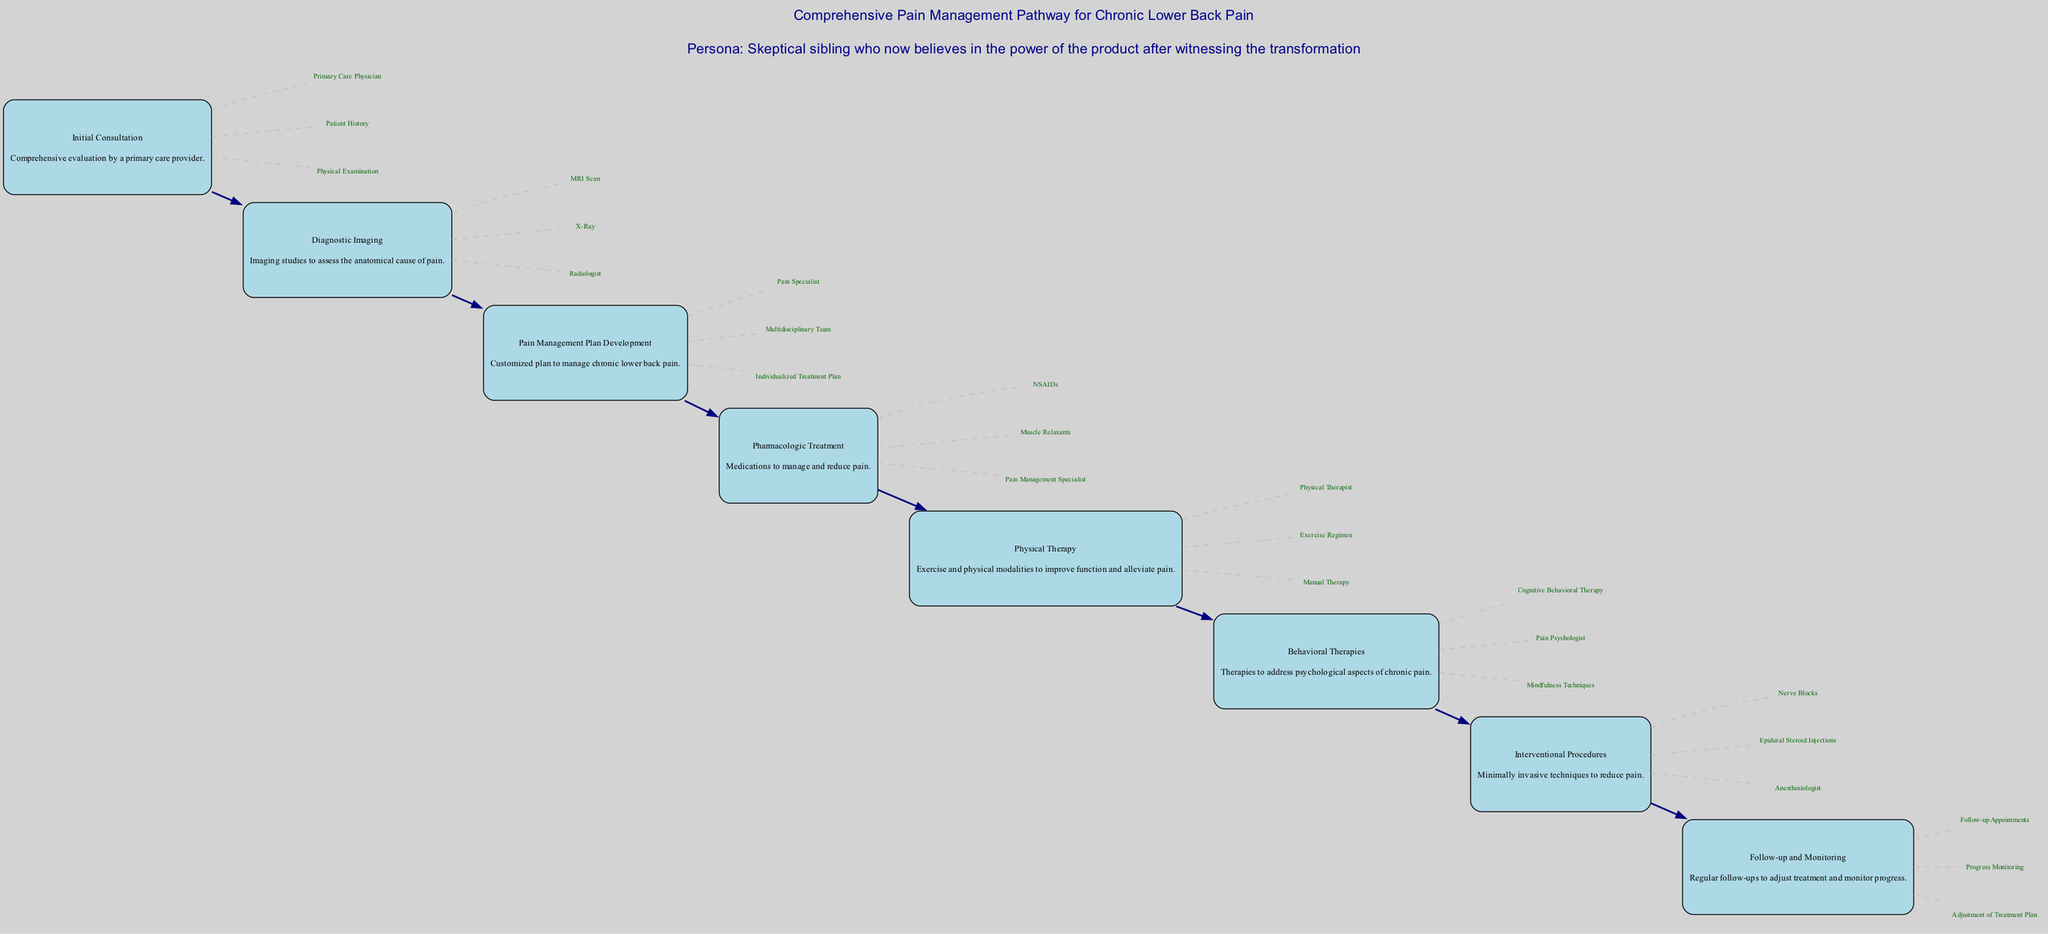What is the first step in the pathway? The first step in the pathway is "Initial Consultation." It is indicated at the beginning of the diagram and is the starting point for the comprehensive pain management process.
Answer: Initial Consultation How many steps are in the pathway? The diagram features eight distinct steps, each representing a critical part of the comprehensive pain management pathway.
Answer: 8 What type of specialist is involved in "Pain Management Plan Development"? The diagram specifies that a "Pain Specialist" is a key entity involved in developing the pain management plan, indicating their role in this step.
Answer: Pain Specialist Which treatment follows Physical Therapy in the pathway? According to the diagram, "Behavioral Therapies" directly follows "Physical Therapy," indicating the sequential nature of the treatment steps in the management pathway.
Answer: Behavioral Therapies What does "Diagnostic Imaging" involve? The diagram indicates that "Diagnostic Imaging" includes imaging studies such as an "MRI Scan" and "X-Ray," which are essential for assessing the anatomical cause of pain.
Answer: MRI Scan, X-Ray How are the steps connected in the pathway? The steps are connected by directed edges showing the flow from one step to the next, indicating the sequence of treatments and evaluations in the pathway from the initial consultation to follow-up and monitoring.
Answer: Directed edges Which process is managed by a Multidisciplinary Team? The "Pain Management Plan Development" involves a "Multidisciplinary Team," which is key to creating a customized plan for managing chronic lower back pain, as shown in the diagram.
Answer: Multidisciplinary Team What does the node for "Follow-up and Monitoring" represent? The node for "Follow-up and Monitoring" represents the regular follow-up appointments and progress monitoring necessary to adjust treatment and ensure patient wellbeing, as indicated in the last step of the diagram.
Answer: Regular follow-ups 